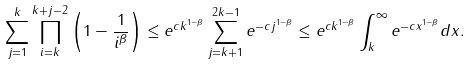Convert formula to latex. <formula><loc_0><loc_0><loc_500><loc_500>\sum _ { j = 1 } ^ { k } \prod _ { i = k } ^ { k + j - 2 } \left ( 1 - \frac { 1 } { i ^ { \beta } } \right ) \leq e ^ { c k ^ { 1 - \beta } } \sum _ { j = k + 1 } ^ { 2 k - 1 } e ^ { - c j ^ { 1 - \beta } } \leq e ^ { c k ^ { 1 - \beta } } \int _ { k } ^ { \infty } e ^ { - c x ^ { 1 - \beta } } d x .</formula> 